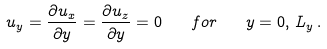Convert formula to latex. <formula><loc_0><loc_0><loc_500><loc_500>u _ { y } = \frac { \partial u _ { x } } { \partial y } = \frac { \partial u _ { z } } { \partial y } = 0 \quad f o r \quad y = 0 , \, L _ { y } \, .</formula> 